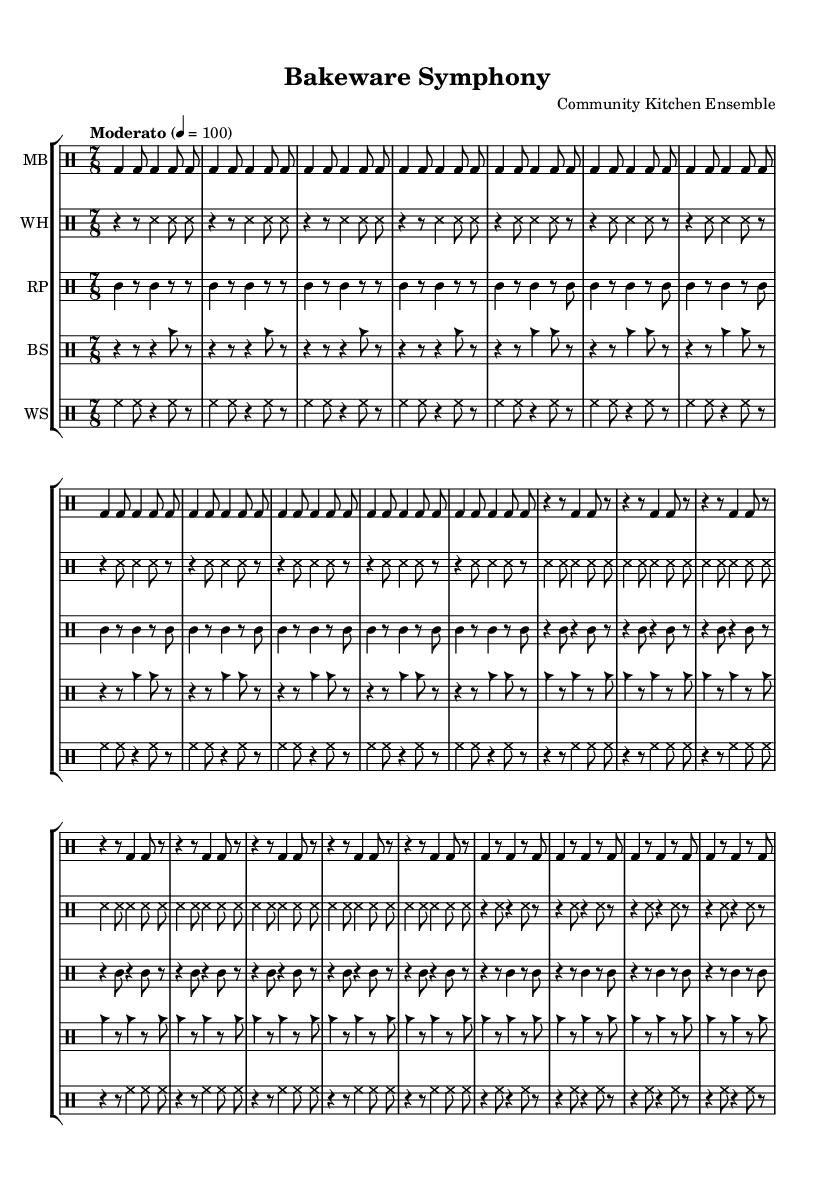What is the time signature of this music? The time signature of the music is indicated at the beginning as 7/8, meaning there are seven beats per measure and the eighth note gets one beat.
Answer: 7/8 What is the tempo marking given? The tempo marking is provided in the score indicating the speed at which the piece should be played; it states "Moderato" at a speed of quarter note equals 100.
Answer: Moderato, 4 = 100 How many different drum staffs are included in the score? The score lists five drum staffs for different instruments, including MB, WH, RP, BS, and WS, as identified in the score layout.
Answer: 5 What is the function of the 'ss' sound in this music? The 'ss' sound is consistently used throughout the score and resembles a sound produced by striking metal objects or kitchen utensils, which contributes to the experimental texture of the piece.
Answer: Metallic sound Which instrument is primarily used for producing the 'bd' sound? The 'bd' sound represents a bass drum, which in this context relates to deeper, resonant percussive sounds typical for creating a foundational rhythm.
Answer: Bass drum What is a unique feature of the score structure that reflects its experimental nature? The piece does not follow a traditional compositional structure; instead, it uses repeated motifs with varying techniques in each part, showcasing creativity in sound production using kitchen utensils.
Answer: Non-traditional structure 